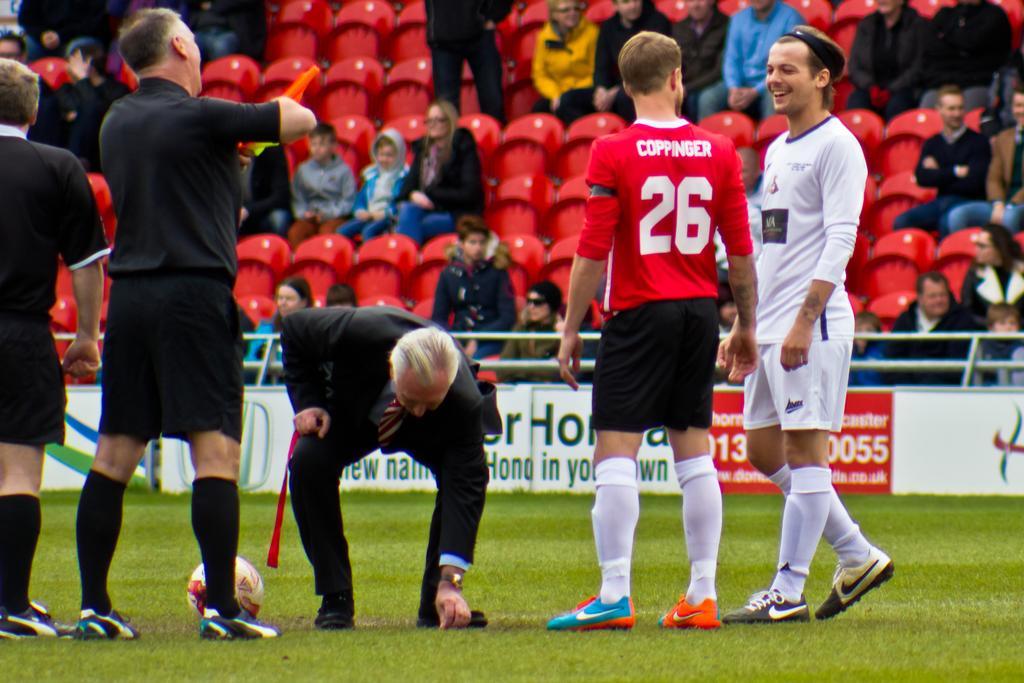Please provide a concise description of this image. In the center of the image there are people standing in grass. In the background of the image there are people sitting in chairs. There is a ball. 